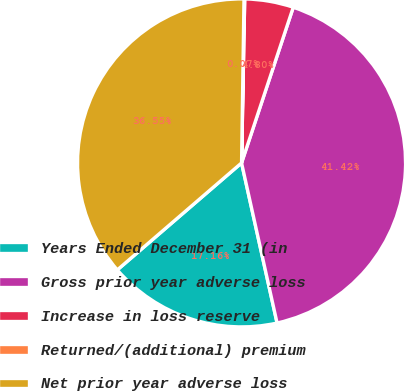<chart> <loc_0><loc_0><loc_500><loc_500><pie_chart><fcel>Years Ended December 31 (in<fcel>Gross prior year adverse loss<fcel>Increase in loss reserve<fcel>Returned/(additional) premium<fcel>Net prior year adverse loss<nl><fcel>17.16%<fcel>41.42%<fcel>4.8%<fcel>0.07%<fcel>36.55%<nl></chart> 